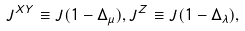<formula> <loc_0><loc_0><loc_500><loc_500>J ^ { X Y } \equiv J ( 1 - \Delta _ { \mu } ) , J ^ { Z } \equiv J ( 1 - \Delta _ { \lambda } ) ,</formula> 